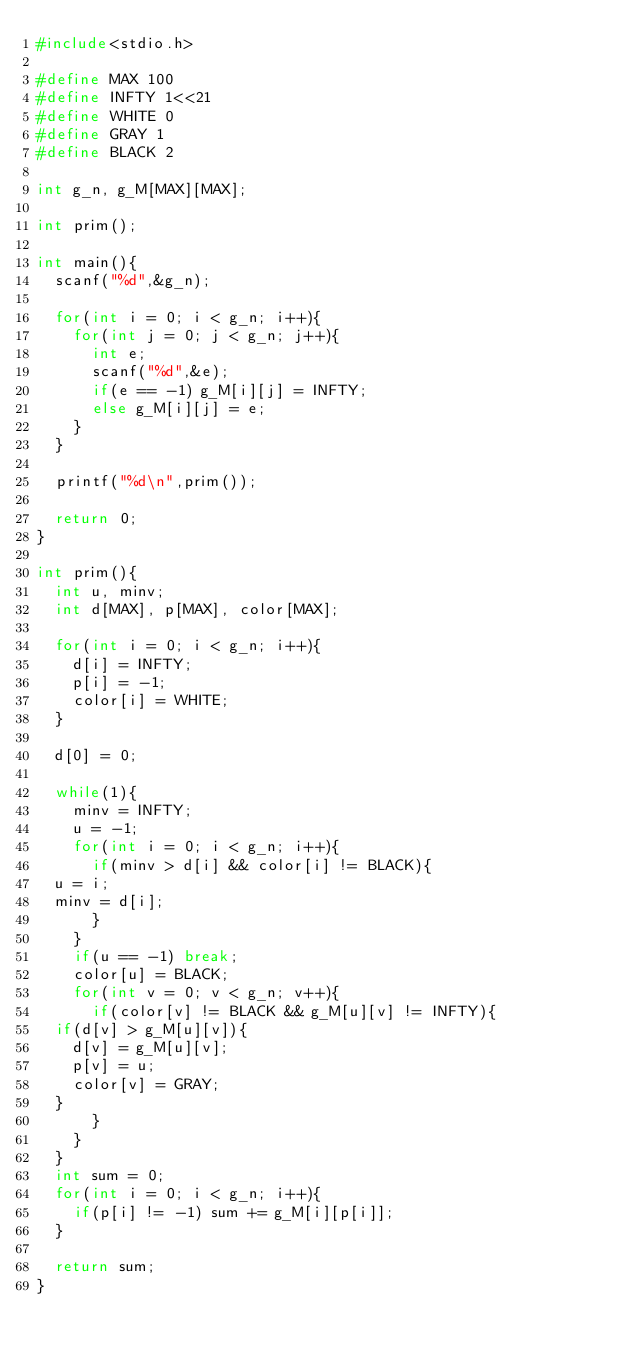<code> <loc_0><loc_0><loc_500><loc_500><_C_>#include<stdio.h>

#define MAX 100
#define INFTY 1<<21
#define WHITE 0
#define GRAY 1
#define BLACK 2

int g_n, g_M[MAX][MAX];

int prim();

int main(){
  scanf("%d",&g_n);
  
  for(int i = 0; i < g_n; i++){
    for(int j = 0; j < g_n; j++){
      int e;
      scanf("%d",&e);
      if(e == -1) g_M[i][j] = INFTY;
      else g_M[i][j] = e;
    }
  }

  printf("%d\n",prim());
  
  return 0;
}

int prim(){
  int u, minv;
  int d[MAX], p[MAX], color[MAX];

  for(int i = 0; i < g_n; i++){
    d[i] = INFTY;
    p[i] = -1;
    color[i] = WHITE;
  }
  
  d[0] = 0;

  while(1){
    minv = INFTY;
    u = -1;
    for(int i = 0; i < g_n; i++){
      if(minv > d[i] && color[i] != BLACK){
	u = i;
	minv = d[i];
      }
    }
    if(u == -1) break;
    color[u] = BLACK;
    for(int v = 0; v < g_n; v++){
      if(color[v] != BLACK && g_M[u][v] != INFTY){
	if(d[v] > g_M[u][v]){
	  d[v] = g_M[u][v];
	  p[v] = u;
	  color[v] = GRAY;
	}
      }
    }
  }
  int sum = 0;
  for(int i = 0; i < g_n; i++){
    if(p[i] != -1) sum += g_M[i][p[i]];
  }

  return sum;
}

</code> 